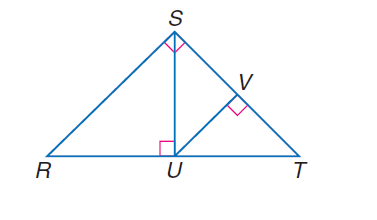Answer the mathemtical geometry problem and directly provide the correct option letter.
Question: If \angle R S T is a right angle, S U \perp R T, U V \perp S T, and m \angle R T S = 47, find m \angle R S U.
Choices: A: 35 B: 37 C: 45 D: 47 D 